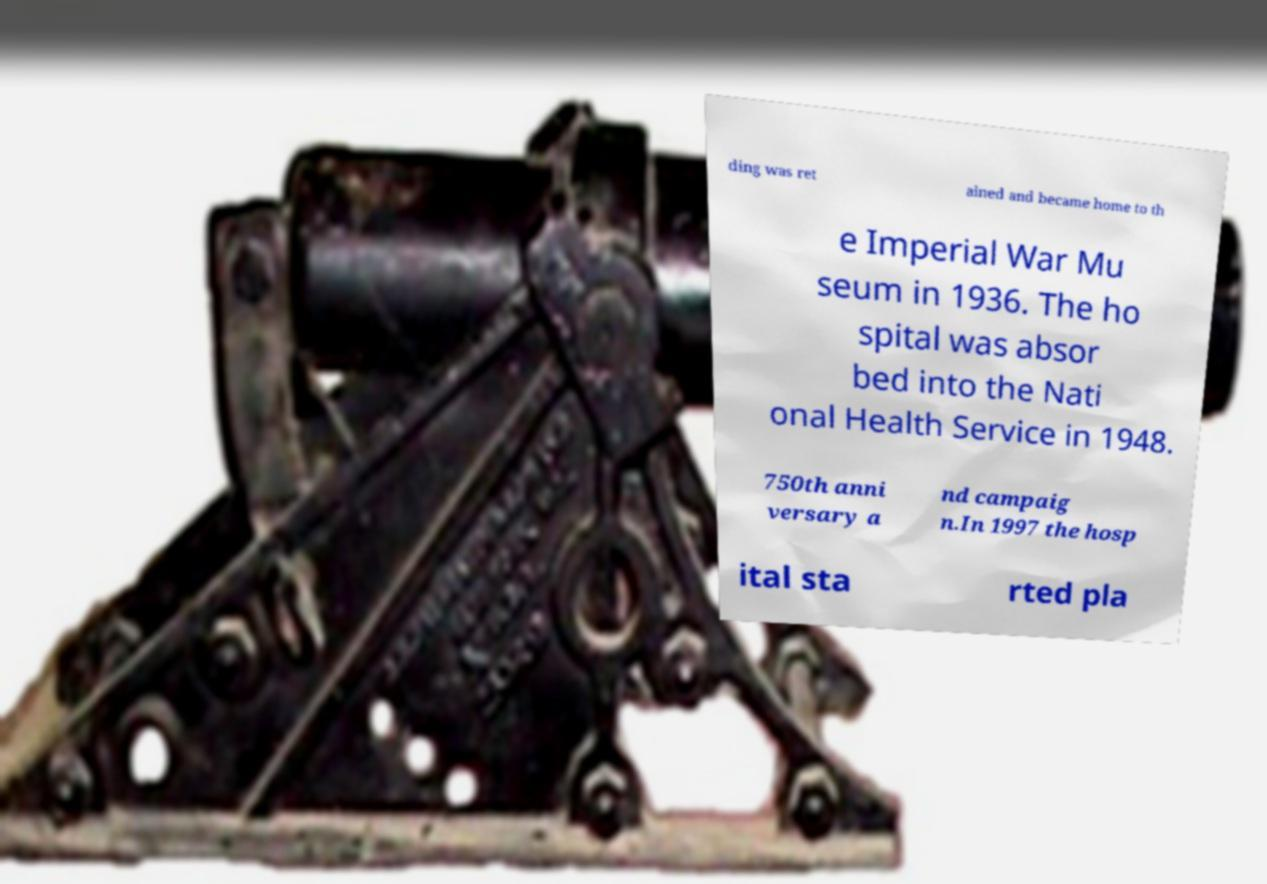Could you assist in decoding the text presented in this image and type it out clearly? ding was ret ained and became home to th e Imperial War Mu seum in 1936. The ho spital was absor bed into the Nati onal Health Service in 1948. 750th anni versary a nd campaig n.In 1997 the hosp ital sta rted pla 